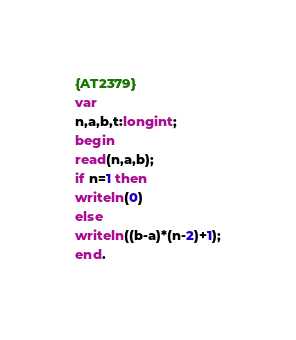<code> <loc_0><loc_0><loc_500><loc_500><_Pascal_>{AT2379}
var
n,a,b,t:longint;
begin
read(n,a,b);
if n=1 then
writeln(0)
else
writeln((b-a)*(n-2)+1);
end.</code> 